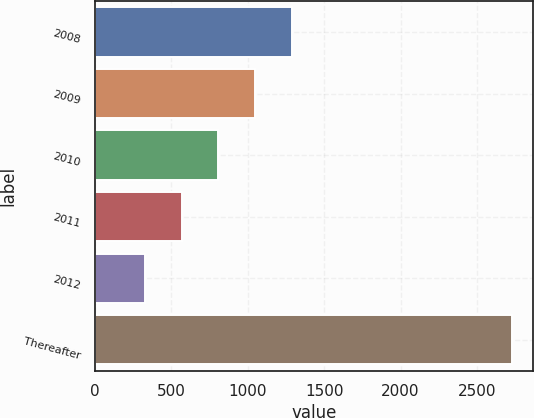Convert chart. <chart><loc_0><loc_0><loc_500><loc_500><bar_chart><fcel>2008<fcel>2009<fcel>2010<fcel>2011<fcel>2012<fcel>Thereafter<nl><fcel>1289.6<fcel>1049.2<fcel>808.8<fcel>568.4<fcel>328<fcel>2732<nl></chart> 